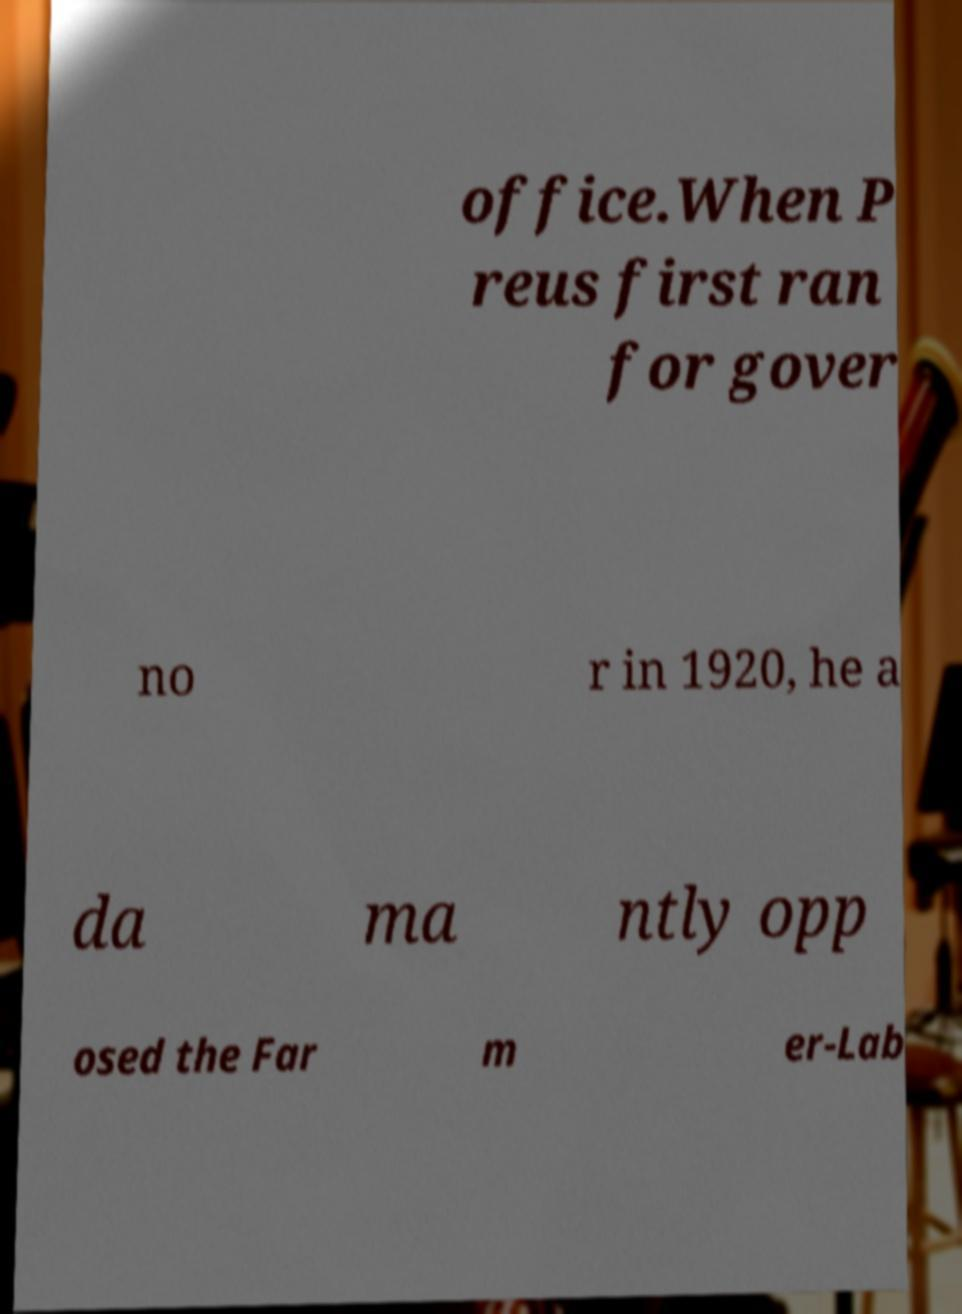Please read and relay the text visible in this image. What does it say? office.When P reus first ran for gover no r in 1920, he a da ma ntly opp osed the Far m er-Lab 